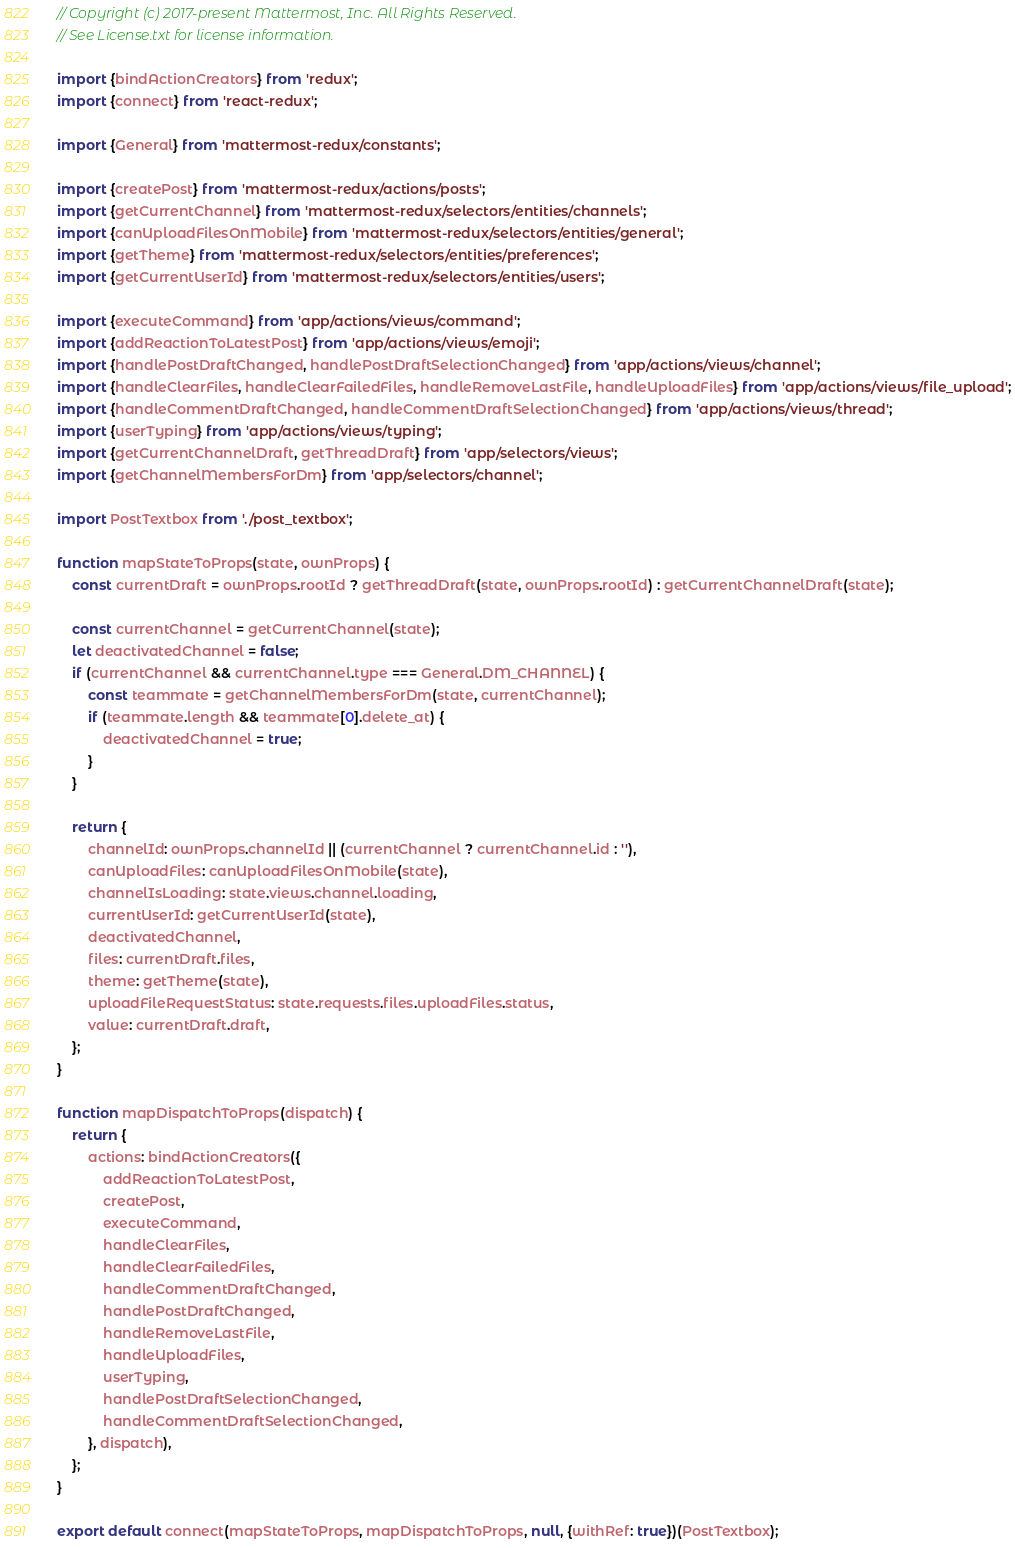<code> <loc_0><loc_0><loc_500><loc_500><_JavaScript_>// Copyright (c) 2017-present Mattermost, Inc. All Rights Reserved.
// See License.txt for license information.

import {bindActionCreators} from 'redux';
import {connect} from 'react-redux';

import {General} from 'mattermost-redux/constants';

import {createPost} from 'mattermost-redux/actions/posts';
import {getCurrentChannel} from 'mattermost-redux/selectors/entities/channels';
import {canUploadFilesOnMobile} from 'mattermost-redux/selectors/entities/general';
import {getTheme} from 'mattermost-redux/selectors/entities/preferences';
import {getCurrentUserId} from 'mattermost-redux/selectors/entities/users';

import {executeCommand} from 'app/actions/views/command';
import {addReactionToLatestPost} from 'app/actions/views/emoji';
import {handlePostDraftChanged, handlePostDraftSelectionChanged} from 'app/actions/views/channel';
import {handleClearFiles, handleClearFailedFiles, handleRemoveLastFile, handleUploadFiles} from 'app/actions/views/file_upload';
import {handleCommentDraftChanged, handleCommentDraftSelectionChanged} from 'app/actions/views/thread';
import {userTyping} from 'app/actions/views/typing';
import {getCurrentChannelDraft, getThreadDraft} from 'app/selectors/views';
import {getChannelMembersForDm} from 'app/selectors/channel';

import PostTextbox from './post_textbox';

function mapStateToProps(state, ownProps) {
    const currentDraft = ownProps.rootId ? getThreadDraft(state, ownProps.rootId) : getCurrentChannelDraft(state);

    const currentChannel = getCurrentChannel(state);
    let deactivatedChannel = false;
    if (currentChannel && currentChannel.type === General.DM_CHANNEL) {
        const teammate = getChannelMembersForDm(state, currentChannel);
        if (teammate.length && teammate[0].delete_at) {
            deactivatedChannel = true;
        }
    }

    return {
        channelId: ownProps.channelId || (currentChannel ? currentChannel.id : ''),
        canUploadFiles: canUploadFilesOnMobile(state),
        channelIsLoading: state.views.channel.loading,
        currentUserId: getCurrentUserId(state),
        deactivatedChannel,
        files: currentDraft.files,
        theme: getTheme(state),
        uploadFileRequestStatus: state.requests.files.uploadFiles.status,
        value: currentDraft.draft,
    };
}

function mapDispatchToProps(dispatch) {
    return {
        actions: bindActionCreators({
            addReactionToLatestPost,
            createPost,
            executeCommand,
            handleClearFiles,
            handleClearFailedFiles,
            handleCommentDraftChanged,
            handlePostDraftChanged,
            handleRemoveLastFile,
            handleUploadFiles,
            userTyping,
            handlePostDraftSelectionChanged,
            handleCommentDraftSelectionChanged,
        }, dispatch),
    };
}

export default connect(mapStateToProps, mapDispatchToProps, null, {withRef: true})(PostTextbox);
</code> 